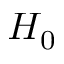Convert formula to latex. <formula><loc_0><loc_0><loc_500><loc_500>H _ { 0 }</formula> 